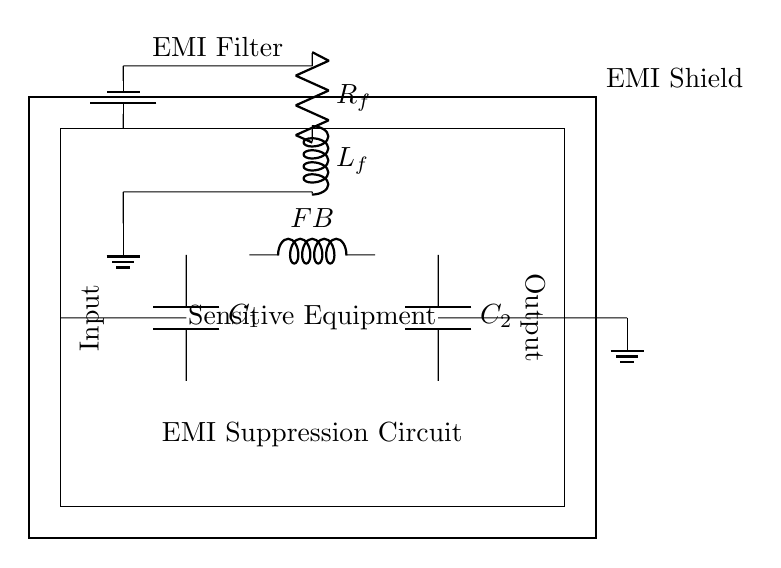What is the purpose of the EMI shield? The EMI shield is designed to protect the sensitive equipment from electromagnetic interference by enclosing it and reducing noise levels.
Answer: Protecting sensitive equipment What type of components are C1 and C2? C1 and C2 are capacitors, which are used in the circuit to suppress high-frequency EMI signals and provide stability to the power supply.
Answer: Capacitors What does the symbol labeled "FB" represent? The symbol labeled "FB" represents a ferrite bead, which is used in circuits to suppress high-frequency noise and ensure clean signal operation.
Answer: Ferrite bead How many resistors are present in the circuit? The circuit has one resistor, labeled Rf, which is part of the EMI filter section to limit the current and reduce interference.
Answer: One What are the two inputs for in the circuit? The two inputs serve as the power source and the signal input to the sensitive equipment, facilitating the necessary operations while maintaining performance.
Answer: Power and signal inputs What is located at the ground reference points? The ground reference points are the locations in the circuit that provide a return path for current, ensuring safety and stability in the system operations.
Answer: Ground connections 